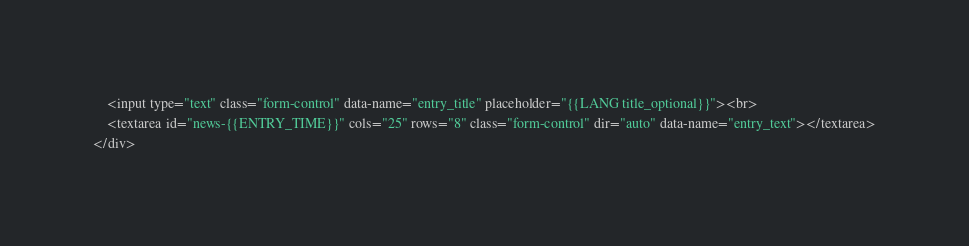Convert code to text. <code><loc_0><loc_0><loc_500><loc_500><_HTML_>	<input type="text" class="form-control" data-name="entry_title" placeholder="{{LANG title_optional}}"><br>
	<textarea id="news-{{ENTRY_TIME}}" cols="25" rows="8" class="form-control" dir="auto" data-name="entry_text"></textarea>
</div></code> 